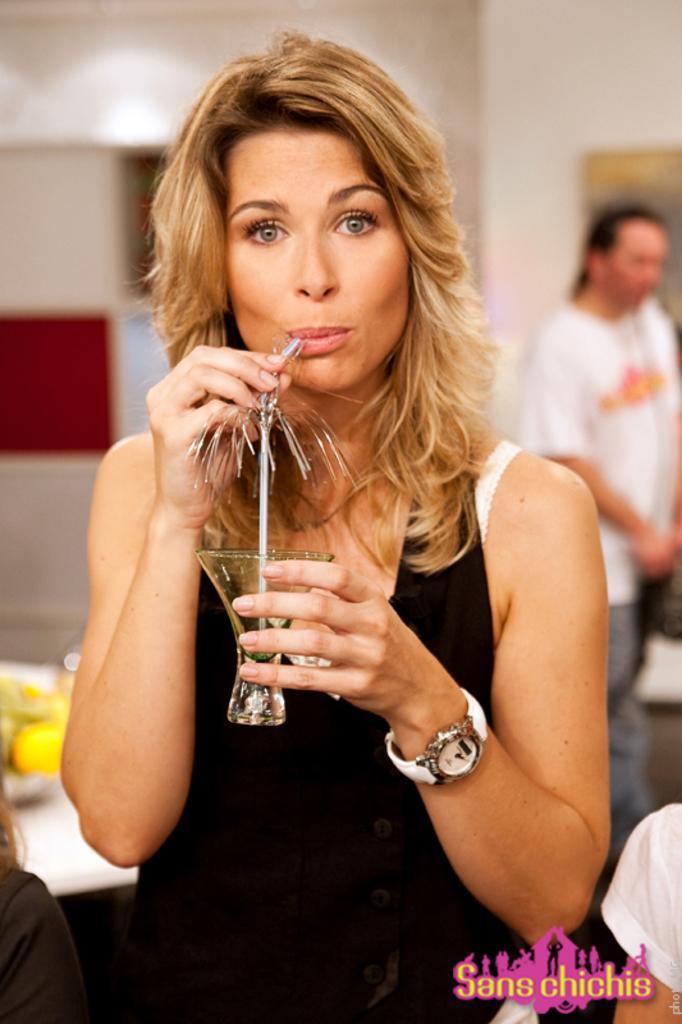Could you give a brief overview of what you see in this image? In this picture there is a woman who is holding a straw and a glass. And she is wearing a black dress. On the right there is a person who is wearing a white T shirt and grey jeans. On the background we can see a colorful wall. On the table there is a fruits. 